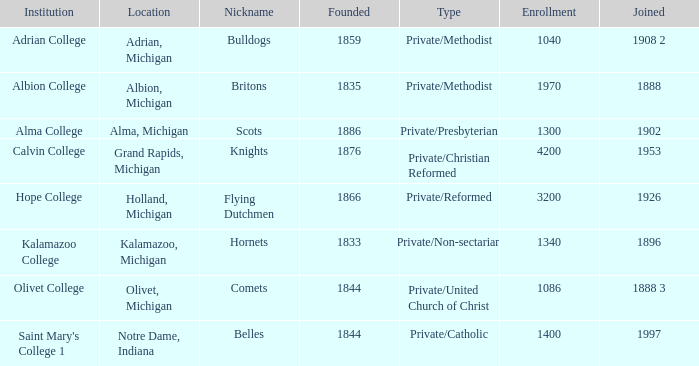Which creation is most possible under belles? 1844.0. 